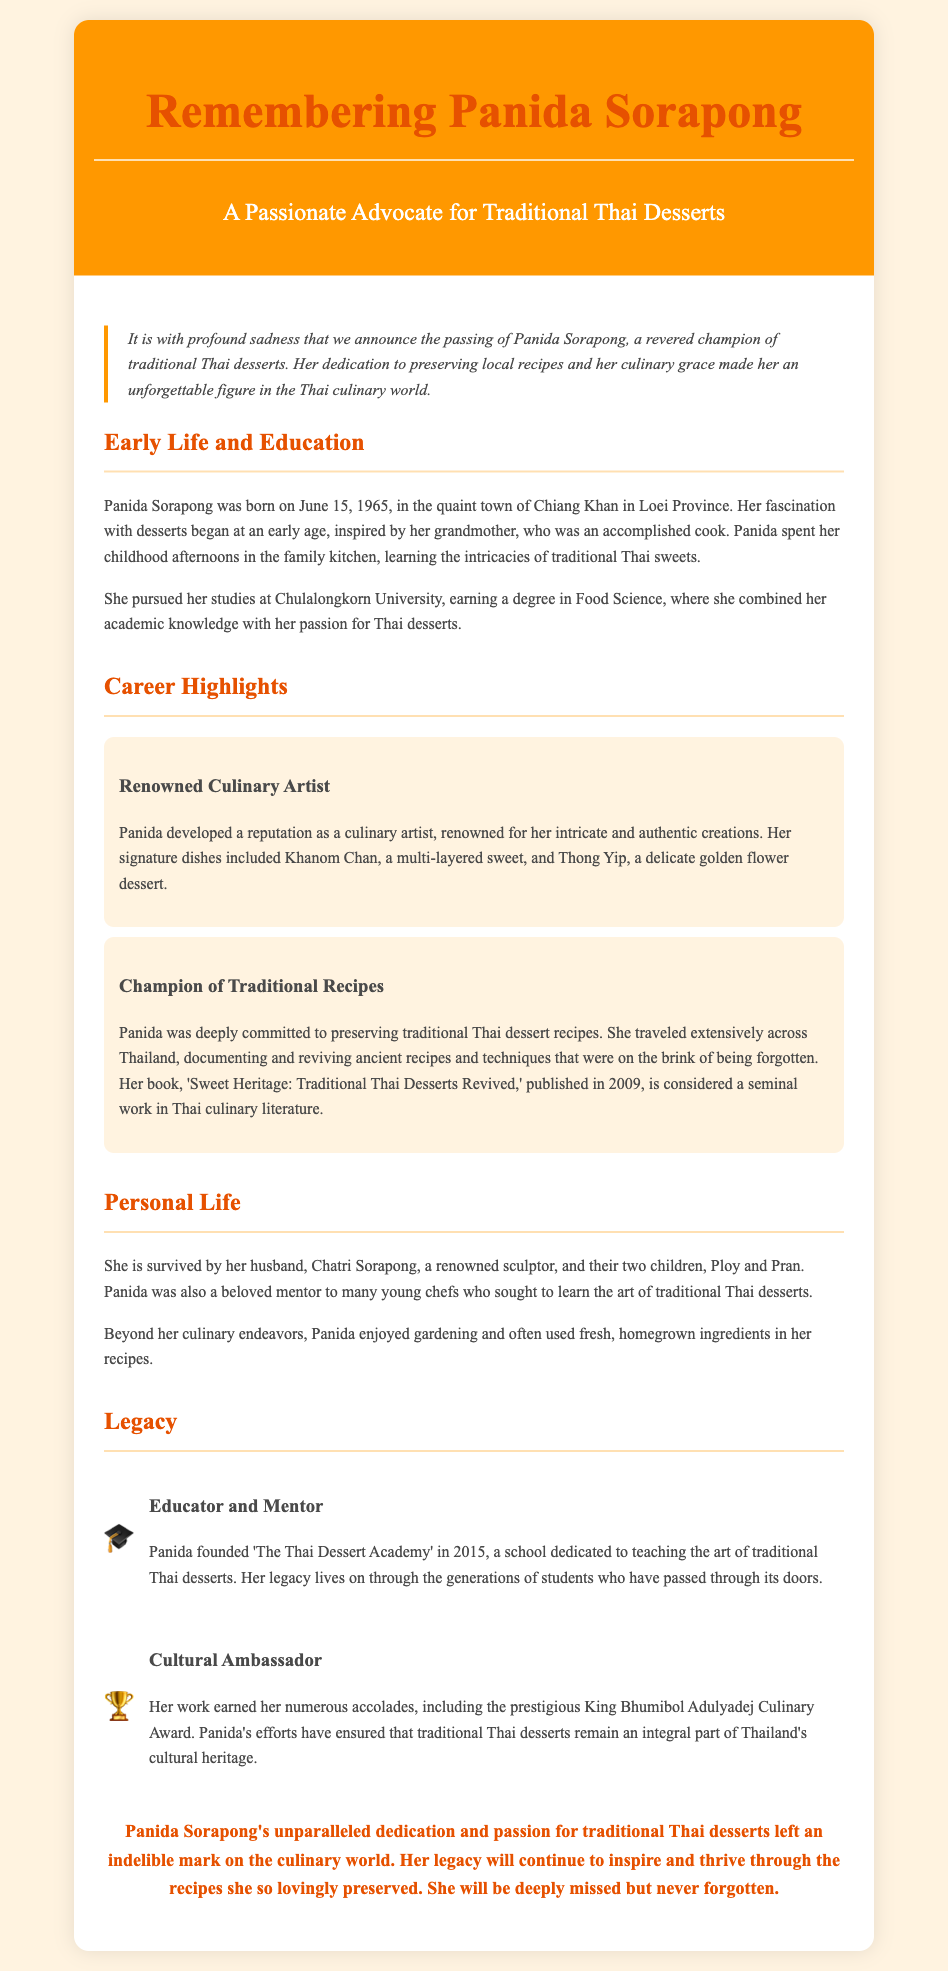What is the birth date of Panida Sorapong? The document states that Panida Sorapong was born on June 15, 1965.
Answer: June 15, 1965 What degree did Panida earn from Chulalongkorn University? The document mentions that she earned a degree in Food Science.
Answer: Food Science What book did Panida publish in 2009? The obituary references her book titled 'Sweet Heritage: Traditional Thai Desserts Revived'.
Answer: Sweet Heritage: Traditional Thai Desserts Revived What is the name of Panida's husband? The document reveals that her husband is Chatri Sorapong.
Answer: Chatri Sorapong In what year did Panida found 'The Thai Dessert Academy'? The document states that 'The Thai Dessert Academy' was founded in 2015.
Answer: 2015 How many children did Panida have? According to the document, Panida is survived by two children.
Answer: Two What culinary award did Panida receive? The obituary mentions that she earned the King Bhumibol Adulyadej Culinary Award.
Answer: King Bhumibol Adulyadej Culinary Award What traditional dish was Panida known for? The document states she was renowned for Khanom Chan.
Answer: Khanom Chan What was the primary focus of Panida's work? The obituary highlights her dedication to preserving traditional Thai dessert recipes.
Answer: Preserving traditional Thai dessert recipes 